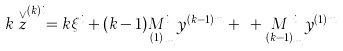<formula> <loc_0><loc_0><loc_500><loc_500>k \stackrel { \vee } { z } ^ { ( k ) i } = k \xi ^ { i } + ( k - 1 ) \underset { ( 1 ) } { M } _ { m } ^ { i } y ^ { ( k - 1 ) m } + \cdots + \underset { ( k - 1 ) } { M } _ { m } ^ { i } y ^ { ( 1 ) m }</formula> 